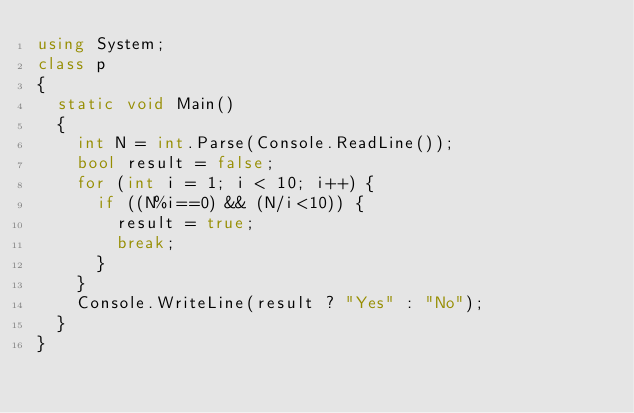Convert code to text. <code><loc_0><loc_0><loc_500><loc_500><_C#_>using System;
class p
{
  static void Main()
  {
    int N = int.Parse(Console.ReadLine());
    bool result = false;
    for (int i = 1; i < 10; i++) {
      if ((N%i==0) && (N/i<10)) {
        result = true;
        break;
      }
    }
    Console.WriteLine(result ? "Yes" : "No");
  }
}</code> 